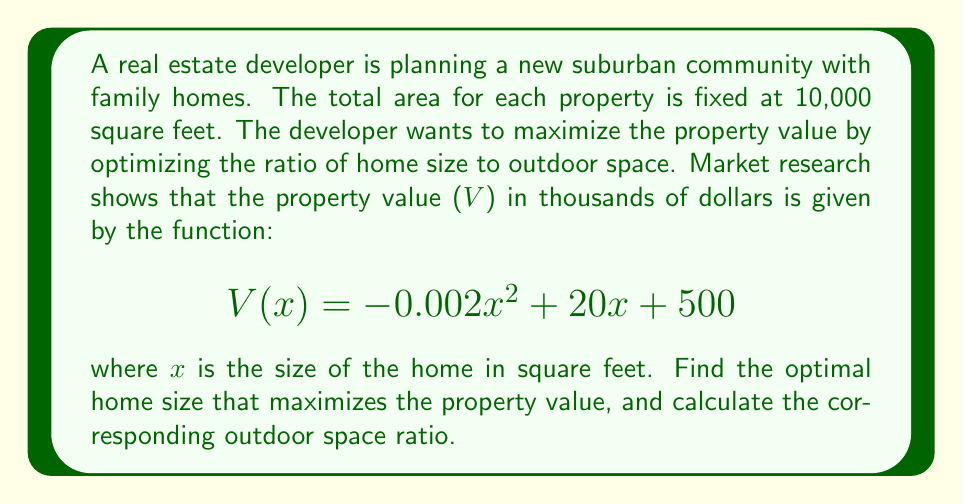Provide a solution to this math problem. 1) To find the maximum value of the function, we need to find the critical point where the derivative equals zero.

2) First, let's find the derivative of V(x):
   $$V'(x) = -0.004x + 20$$

3) Set the derivative equal to zero and solve for x:
   $$-0.004x + 20 = 0$$
   $$-0.004x = -20$$
   $$x = 5000$$

4) The second derivative is negative ($V''(x) = -0.004 < 0$), confirming this is a maximum.

5) Therefore, the optimal home size is 5000 square feet.

6) To calculate the outdoor space ratio:
   Total property size: 10,000 sq ft
   Home size: 5,000 sq ft
   Outdoor space: 10,000 - 5,000 = 5,000 sq ft

   Ratio of outdoor space to total property size:
   $$\frac{5000}{10000} = \frac{1}{2} = 0.5$$

7) The outdoor space ratio is 0.5 or 50%.
Answer: Optimal home size: 5000 sq ft; Outdoor space ratio: 0.5 